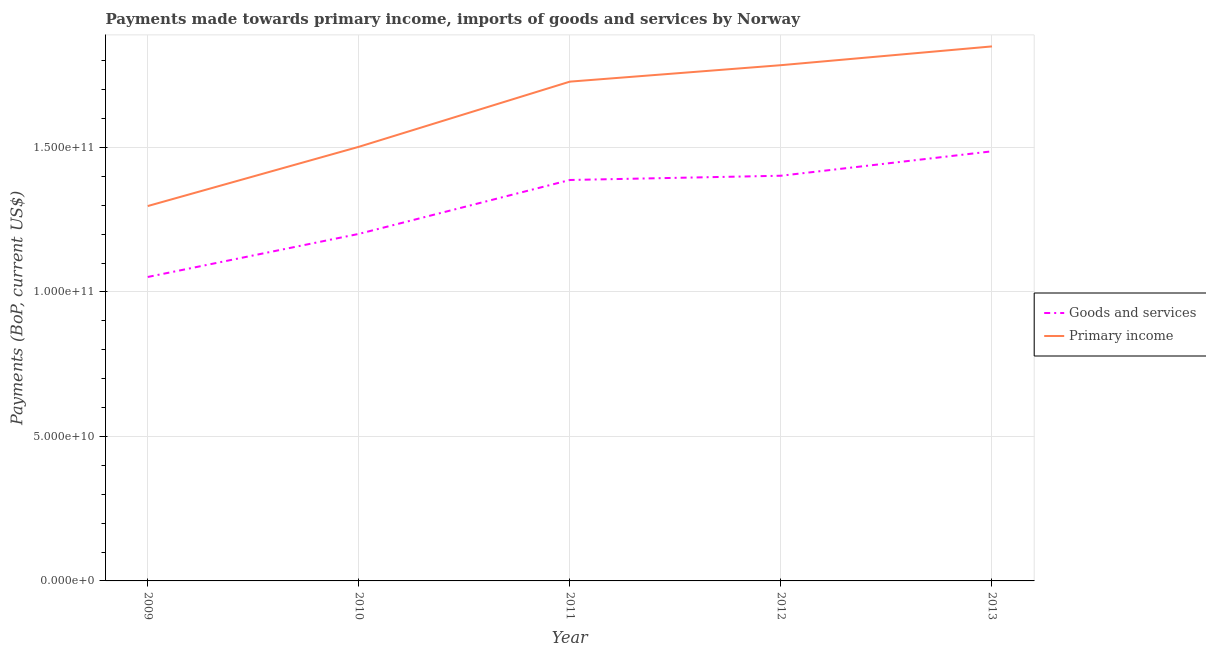How many different coloured lines are there?
Your answer should be very brief. 2. What is the payments made towards goods and services in 2010?
Your answer should be compact. 1.20e+11. Across all years, what is the maximum payments made towards primary income?
Offer a terse response. 1.85e+11. Across all years, what is the minimum payments made towards goods and services?
Your answer should be compact. 1.05e+11. In which year was the payments made towards primary income maximum?
Provide a succinct answer. 2013. What is the total payments made towards goods and services in the graph?
Give a very brief answer. 6.53e+11. What is the difference between the payments made towards goods and services in 2011 and that in 2013?
Provide a succinct answer. -9.93e+09. What is the difference between the payments made towards primary income in 2011 and the payments made towards goods and services in 2010?
Offer a terse response. 5.27e+1. What is the average payments made towards goods and services per year?
Ensure brevity in your answer.  1.31e+11. In the year 2011, what is the difference between the payments made towards primary income and payments made towards goods and services?
Your response must be concise. 3.40e+1. What is the ratio of the payments made towards primary income in 2012 to that in 2013?
Your response must be concise. 0.96. Is the payments made towards goods and services in 2009 less than that in 2010?
Offer a very short reply. Yes. Is the difference between the payments made towards goods and services in 2012 and 2013 greater than the difference between the payments made towards primary income in 2012 and 2013?
Your answer should be very brief. No. What is the difference between the highest and the second highest payments made towards primary income?
Ensure brevity in your answer.  6.50e+09. What is the difference between the highest and the lowest payments made towards primary income?
Your response must be concise. 5.53e+1. Is the sum of the payments made towards primary income in 2010 and 2011 greater than the maximum payments made towards goods and services across all years?
Your answer should be very brief. Yes. Is the payments made towards goods and services strictly less than the payments made towards primary income over the years?
Offer a terse response. Yes. How many lines are there?
Keep it short and to the point. 2. How many years are there in the graph?
Make the answer very short. 5. What is the difference between two consecutive major ticks on the Y-axis?
Your response must be concise. 5.00e+1. Does the graph contain any zero values?
Make the answer very short. No. How are the legend labels stacked?
Give a very brief answer. Vertical. What is the title of the graph?
Your answer should be very brief. Payments made towards primary income, imports of goods and services by Norway. Does "Methane emissions" appear as one of the legend labels in the graph?
Your answer should be very brief. No. What is the label or title of the X-axis?
Provide a short and direct response. Year. What is the label or title of the Y-axis?
Your response must be concise. Payments (BoP, current US$). What is the Payments (BoP, current US$) in Goods and services in 2009?
Your answer should be very brief. 1.05e+11. What is the Payments (BoP, current US$) in Primary income in 2009?
Make the answer very short. 1.30e+11. What is the Payments (BoP, current US$) in Goods and services in 2010?
Offer a terse response. 1.20e+11. What is the Payments (BoP, current US$) of Primary income in 2010?
Keep it short and to the point. 1.50e+11. What is the Payments (BoP, current US$) of Goods and services in 2011?
Make the answer very short. 1.39e+11. What is the Payments (BoP, current US$) in Primary income in 2011?
Provide a succinct answer. 1.73e+11. What is the Payments (BoP, current US$) in Goods and services in 2012?
Provide a short and direct response. 1.40e+11. What is the Payments (BoP, current US$) of Primary income in 2012?
Your answer should be very brief. 1.79e+11. What is the Payments (BoP, current US$) in Goods and services in 2013?
Your response must be concise. 1.49e+11. What is the Payments (BoP, current US$) of Primary income in 2013?
Give a very brief answer. 1.85e+11. Across all years, what is the maximum Payments (BoP, current US$) in Goods and services?
Your answer should be compact. 1.49e+11. Across all years, what is the maximum Payments (BoP, current US$) in Primary income?
Make the answer very short. 1.85e+11. Across all years, what is the minimum Payments (BoP, current US$) in Goods and services?
Give a very brief answer. 1.05e+11. Across all years, what is the minimum Payments (BoP, current US$) in Primary income?
Give a very brief answer. 1.30e+11. What is the total Payments (BoP, current US$) in Goods and services in the graph?
Offer a terse response. 6.53e+11. What is the total Payments (BoP, current US$) of Primary income in the graph?
Your answer should be very brief. 8.16e+11. What is the difference between the Payments (BoP, current US$) in Goods and services in 2009 and that in 2010?
Your answer should be compact. -1.49e+1. What is the difference between the Payments (BoP, current US$) of Primary income in 2009 and that in 2010?
Your response must be concise. -2.05e+1. What is the difference between the Payments (BoP, current US$) in Goods and services in 2009 and that in 2011?
Your answer should be very brief. -3.36e+1. What is the difference between the Payments (BoP, current US$) in Primary income in 2009 and that in 2011?
Provide a succinct answer. -4.31e+1. What is the difference between the Payments (BoP, current US$) in Goods and services in 2009 and that in 2012?
Provide a short and direct response. -3.50e+1. What is the difference between the Payments (BoP, current US$) of Primary income in 2009 and that in 2012?
Offer a very short reply. -4.88e+1. What is the difference between the Payments (BoP, current US$) of Goods and services in 2009 and that in 2013?
Your response must be concise. -4.35e+1. What is the difference between the Payments (BoP, current US$) of Primary income in 2009 and that in 2013?
Your response must be concise. -5.53e+1. What is the difference between the Payments (BoP, current US$) in Goods and services in 2010 and that in 2011?
Provide a succinct answer. -1.87e+1. What is the difference between the Payments (BoP, current US$) of Primary income in 2010 and that in 2011?
Your response must be concise. -2.26e+1. What is the difference between the Payments (BoP, current US$) in Goods and services in 2010 and that in 2012?
Offer a very short reply. -2.01e+1. What is the difference between the Payments (BoP, current US$) in Primary income in 2010 and that in 2012?
Offer a terse response. -2.83e+1. What is the difference between the Payments (BoP, current US$) in Goods and services in 2010 and that in 2013?
Make the answer very short. -2.86e+1. What is the difference between the Payments (BoP, current US$) in Primary income in 2010 and that in 2013?
Provide a short and direct response. -3.48e+1. What is the difference between the Payments (BoP, current US$) of Goods and services in 2011 and that in 2012?
Make the answer very short. -1.47e+09. What is the difference between the Payments (BoP, current US$) in Primary income in 2011 and that in 2012?
Offer a very short reply. -5.70e+09. What is the difference between the Payments (BoP, current US$) of Goods and services in 2011 and that in 2013?
Keep it short and to the point. -9.93e+09. What is the difference between the Payments (BoP, current US$) in Primary income in 2011 and that in 2013?
Make the answer very short. -1.22e+1. What is the difference between the Payments (BoP, current US$) in Goods and services in 2012 and that in 2013?
Your answer should be compact. -8.45e+09. What is the difference between the Payments (BoP, current US$) in Primary income in 2012 and that in 2013?
Ensure brevity in your answer.  -6.50e+09. What is the difference between the Payments (BoP, current US$) in Goods and services in 2009 and the Payments (BoP, current US$) in Primary income in 2010?
Provide a short and direct response. -4.51e+1. What is the difference between the Payments (BoP, current US$) of Goods and services in 2009 and the Payments (BoP, current US$) of Primary income in 2011?
Your response must be concise. -6.76e+1. What is the difference between the Payments (BoP, current US$) in Goods and services in 2009 and the Payments (BoP, current US$) in Primary income in 2012?
Offer a terse response. -7.33e+1. What is the difference between the Payments (BoP, current US$) of Goods and services in 2009 and the Payments (BoP, current US$) of Primary income in 2013?
Your answer should be very brief. -7.98e+1. What is the difference between the Payments (BoP, current US$) of Goods and services in 2010 and the Payments (BoP, current US$) of Primary income in 2011?
Keep it short and to the point. -5.27e+1. What is the difference between the Payments (BoP, current US$) of Goods and services in 2010 and the Payments (BoP, current US$) of Primary income in 2012?
Your response must be concise. -5.84e+1. What is the difference between the Payments (BoP, current US$) in Goods and services in 2010 and the Payments (BoP, current US$) in Primary income in 2013?
Give a very brief answer. -6.49e+1. What is the difference between the Payments (BoP, current US$) in Goods and services in 2011 and the Payments (BoP, current US$) in Primary income in 2012?
Your response must be concise. -3.97e+1. What is the difference between the Payments (BoP, current US$) in Goods and services in 2011 and the Payments (BoP, current US$) in Primary income in 2013?
Provide a succinct answer. -4.62e+1. What is the difference between the Payments (BoP, current US$) of Goods and services in 2012 and the Payments (BoP, current US$) of Primary income in 2013?
Offer a terse response. -4.48e+1. What is the average Payments (BoP, current US$) in Goods and services per year?
Ensure brevity in your answer.  1.31e+11. What is the average Payments (BoP, current US$) in Primary income per year?
Give a very brief answer. 1.63e+11. In the year 2009, what is the difference between the Payments (BoP, current US$) in Goods and services and Payments (BoP, current US$) in Primary income?
Your answer should be compact. -2.45e+1. In the year 2010, what is the difference between the Payments (BoP, current US$) in Goods and services and Payments (BoP, current US$) in Primary income?
Provide a succinct answer. -3.01e+1. In the year 2011, what is the difference between the Payments (BoP, current US$) of Goods and services and Payments (BoP, current US$) of Primary income?
Your answer should be very brief. -3.40e+1. In the year 2012, what is the difference between the Payments (BoP, current US$) in Goods and services and Payments (BoP, current US$) in Primary income?
Your response must be concise. -3.83e+1. In the year 2013, what is the difference between the Payments (BoP, current US$) in Goods and services and Payments (BoP, current US$) in Primary income?
Your response must be concise. -3.63e+1. What is the ratio of the Payments (BoP, current US$) in Goods and services in 2009 to that in 2010?
Offer a terse response. 0.88. What is the ratio of the Payments (BoP, current US$) of Primary income in 2009 to that in 2010?
Provide a short and direct response. 0.86. What is the ratio of the Payments (BoP, current US$) in Goods and services in 2009 to that in 2011?
Offer a very short reply. 0.76. What is the ratio of the Payments (BoP, current US$) of Primary income in 2009 to that in 2011?
Give a very brief answer. 0.75. What is the ratio of the Payments (BoP, current US$) in Goods and services in 2009 to that in 2012?
Provide a short and direct response. 0.75. What is the ratio of the Payments (BoP, current US$) in Primary income in 2009 to that in 2012?
Your response must be concise. 0.73. What is the ratio of the Payments (BoP, current US$) in Goods and services in 2009 to that in 2013?
Make the answer very short. 0.71. What is the ratio of the Payments (BoP, current US$) in Primary income in 2009 to that in 2013?
Give a very brief answer. 0.7. What is the ratio of the Payments (BoP, current US$) of Goods and services in 2010 to that in 2011?
Ensure brevity in your answer.  0.87. What is the ratio of the Payments (BoP, current US$) in Primary income in 2010 to that in 2011?
Your answer should be compact. 0.87. What is the ratio of the Payments (BoP, current US$) in Goods and services in 2010 to that in 2012?
Make the answer very short. 0.86. What is the ratio of the Payments (BoP, current US$) in Primary income in 2010 to that in 2012?
Ensure brevity in your answer.  0.84. What is the ratio of the Payments (BoP, current US$) in Goods and services in 2010 to that in 2013?
Give a very brief answer. 0.81. What is the ratio of the Payments (BoP, current US$) of Primary income in 2010 to that in 2013?
Provide a succinct answer. 0.81. What is the ratio of the Payments (BoP, current US$) of Goods and services in 2011 to that in 2012?
Your answer should be compact. 0.99. What is the ratio of the Payments (BoP, current US$) in Primary income in 2011 to that in 2012?
Keep it short and to the point. 0.97. What is the ratio of the Payments (BoP, current US$) of Goods and services in 2011 to that in 2013?
Give a very brief answer. 0.93. What is the ratio of the Payments (BoP, current US$) in Primary income in 2011 to that in 2013?
Provide a succinct answer. 0.93. What is the ratio of the Payments (BoP, current US$) in Goods and services in 2012 to that in 2013?
Your response must be concise. 0.94. What is the ratio of the Payments (BoP, current US$) of Primary income in 2012 to that in 2013?
Provide a short and direct response. 0.96. What is the difference between the highest and the second highest Payments (BoP, current US$) in Goods and services?
Ensure brevity in your answer.  8.45e+09. What is the difference between the highest and the second highest Payments (BoP, current US$) in Primary income?
Offer a very short reply. 6.50e+09. What is the difference between the highest and the lowest Payments (BoP, current US$) of Goods and services?
Make the answer very short. 4.35e+1. What is the difference between the highest and the lowest Payments (BoP, current US$) in Primary income?
Make the answer very short. 5.53e+1. 